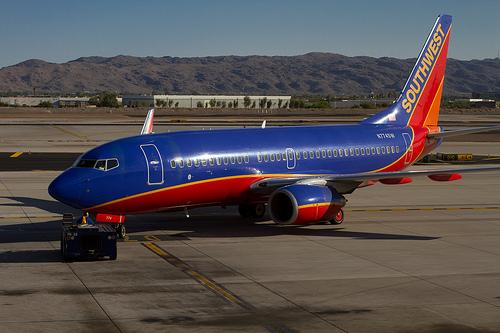Is there a logo present in the image and if so, what is it and where is it situated? Yes, there is a Southwest Airlines logo on the airplane, visible on the tail. Mention any distinctive markings on the plane. The plane has a blue nose, a red stripe on the wing, and an orange stripe on the wing. What is displayed on the tail of the airplane? The word "Southwest" is displayed on the tail of the airplane. Assess whether the image quality is low, medium, or high. Unable to determine image quality without an actual image. Identify the type of spill present on the ground. There is an oil spill on the ground. Explain how the airliner and the cart are interacting in this image. The airliner is being pushed out onto the runway by the cart, which is positioned next to it. Describe the geographical background observable in the image. Mountains can be seen in the background and the sky is blue and clear. Express the general sentiment or emotion that the image conveys. The image conveys a sense of preparation and readiness, as the plane is being pushed onto the runway. Count the number of windows mentioned in the annotations related to the cockpit area. There are 4 windows mentioned in the annotations related to the cockpit area. What vehicle is being used to move the airplane in reverse on the runway? A cart is being used to push the airliner on the runway. Are there flames coming out of the plane's engine? There is no information about flames or any malfunction in the plane's engine. The engine is described as a "large engine on wing of plane" or "planes jet engine" but nothing about flames. Create a short description of the image using a combination of the following elements: airline, weather, and location. A Southwest Airlines plane on a runway with a blue and clear sky, surrounded by mountains Describe the weather conditions visible in the image. Blue and clear sky Can you discern any text on the airplane's tail? Yes, the word "Southwest" Are the mountains covered in snow and ice? No, it's not mentioned in the image. In which order are the cockpit windows situated from left to right?  b) first, second, third Is the sky green and filled with clouds in the image? The sky is described as a "blue and clear sky" in the given information, which means it is not green and cloudy. Can you see the pilot waving from the cockpit window? Although we have information about the cockpit windows and the pilot, there is no mention of the pilot waving or doing any specific action. Is there a huge crack on the tarmac under the plane? There is no mention of a crack or any damage to the tarmac in the provided information. There is an "oil spill on the ground" and "yellow line on the tarmac," but no mention of a crack. List three distinct features found on the plane. Blue nose, red stripe on wing, windows on side of the plane What is happening in the image that involves a person? Person riding on the cart What type of doors are on the side of the plane? Main cabin door and emergency door What type of engine does the plane have? Jet engine What color is the stripe on the wing of the plane? Red Identify the airline of the flight. Southwest Airlines What is the purpose of the yellow line on the tarmac? To guide aircraft and vehicles on the ground Provide a brief description of the structure of the airport and its surroundings. Paved tarmac, mountains in the background, and a Southwest Airlines plane What elements of the image indicate that the setting is an airport? Paved tarmac, airplane, pushback tug, yellow guidance line What is the logo on the airplane? Southwest What vehicle is used to push the plane in reverse? A pushback tug What is the relationship between the cart and the plane in the image? The cart is next to the plane Is there an oil spill visible on the ground? Yes What is being pushed onto the runway? An airliner What is the scene taking place in this image? A plane on a runway being pushed out by a vehicle, with mountains in the background 